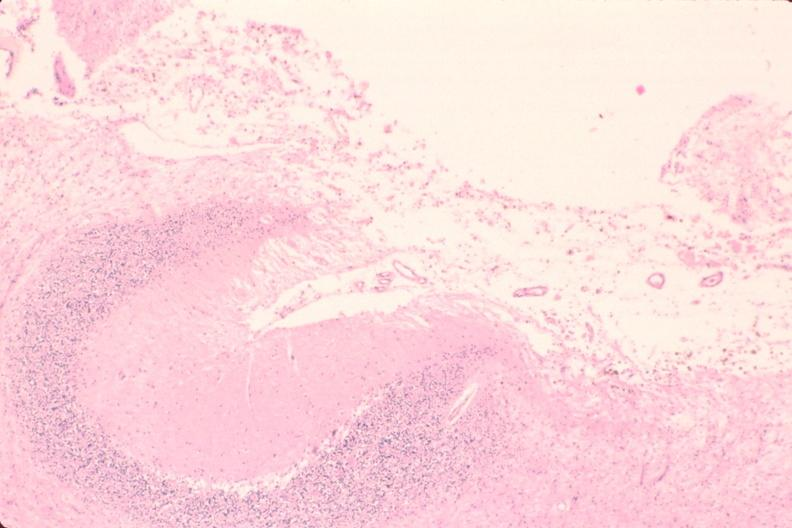what does this image show?
Answer the question using a single word or phrase. Brain 